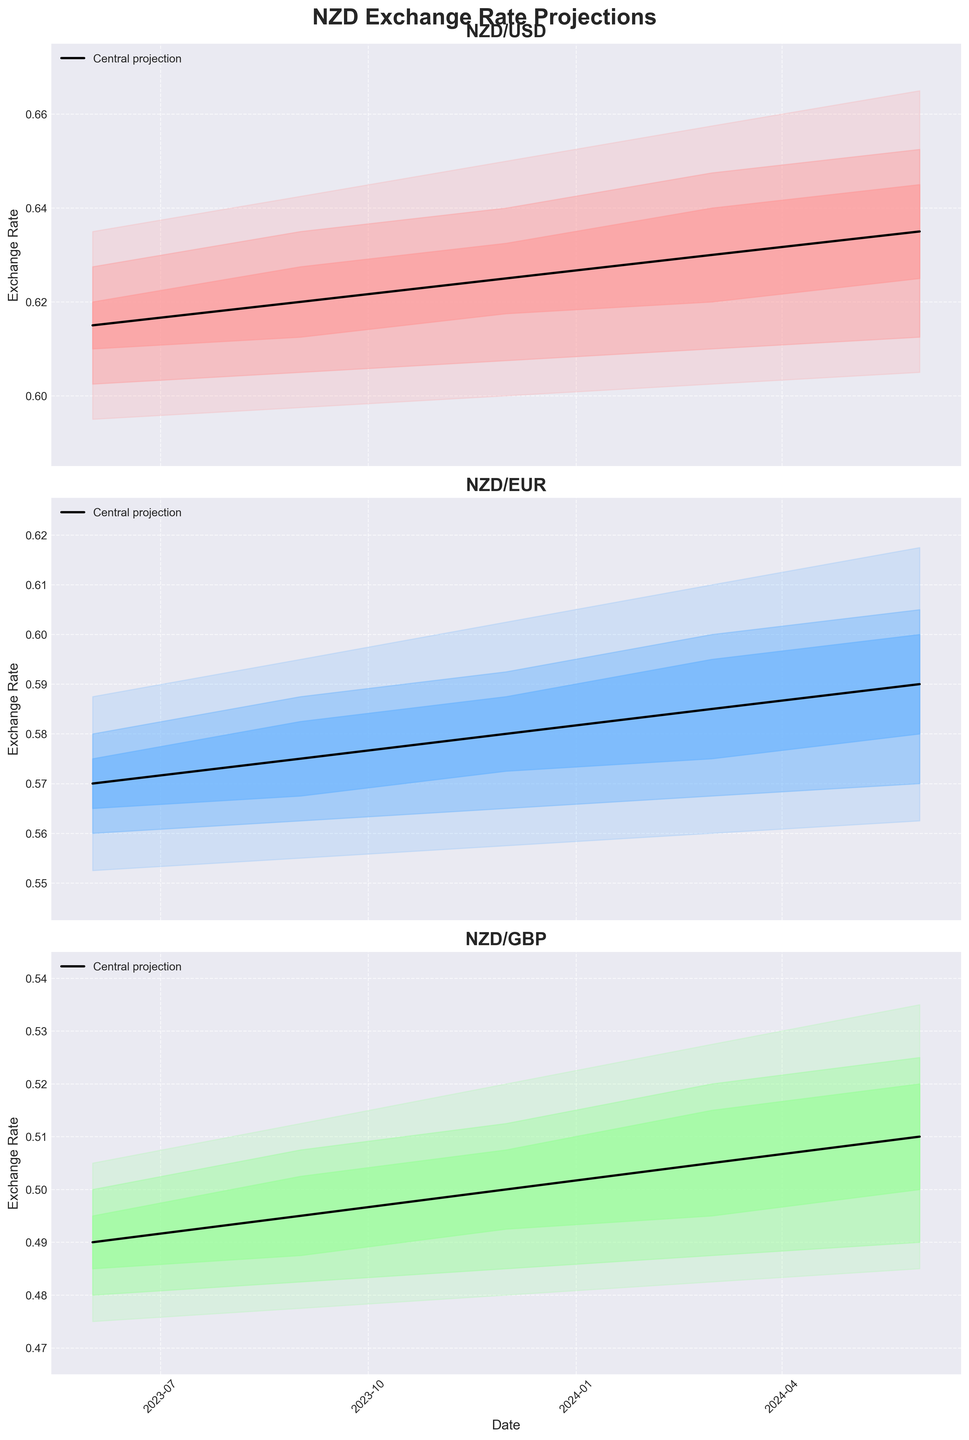What is the title of the chart? The chart's title is displayed at the top of the figure, usually in a larger font size and often bold to make it stand out. In this case, it is "NZD Exchange Rate Projections."
Answer: NZD Exchange Rate Projections How many currencies are projected in the chart? By looking at the subplots, we can see the currency symbols (USD, EUR, GBP) mentioned in each subplot. Thus, there are three currencies projected.
Answer: 3 In which year is the highest central projection for USD expected? The central projection line for USD shows the highest value around 0.6350 in 2024, which is evident by looking at the peak of the central line trend.
Answer: 2024 What is the range of the 95% confidence interval for NZD/EUR on June 1, 2024? To find this, look at the endpoints of the widest band (95% confidence interval) for EUR on the specified date. The lower bound is 0.5625, and the upper bound is 0.6175.
Answer: 0.5625 to 0.6175 Does the central projection of NZD/USD increase steadily over the projected dates? By examining the central projection line for the NZD/USD subplot, we see a consistent upward trend without any major drops, indicating a steady increase.
Answer: Yes Which currency is projected to have the most significant increase in central projections by June 2024 compared to June 2023? To determine this, observe the difference between the central projection values from the start date to the end date for all three currencies. NZD/USD increases from 0.6150 to 0.6350, NZD/EUR from 0.5700 to 0.5900, and NZD/GBP from 0.4900 to 0.5100. Hence, USD has the most significant increase.
Answer: USD What can be inferred from the overlapping confidence bands for NZD/GBP in March 2024? The overlapping confidence bands (50%, 75%, and 95%) around March 2024 indicate higher uncertainty or variability in projections, suggesting that the exchange rate in this period is less predictable.
Answer: Higher uncertainty On which date is the 75% confidence interval for NZD/USD the narrowest? Examining the 75% confidence intervals (the mid-width shaded areas), the narrowest band appears for the date June 1, 2023.
Answer: June 1, 2023 By how much does the upper bound of the 75% confidence interval for NZD/EUR change from September 2023 to December 2023? For NZD/EUR, the upper bound of the 75% confidence interval in September 2023 is 0.5875 and in December 2023 is 0.5925. The difference is calculated as 0.5925 - 0.5875 = 0.005.
Answer: 0.005 